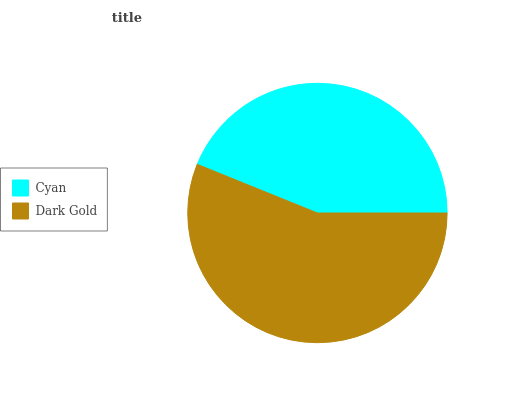Is Cyan the minimum?
Answer yes or no. Yes. Is Dark Gold the maximum?
Answer yes or no. Yes. Is Dark Gold the minimum?
Answer yes or no. No. Is Dark Gold greater than Cyan?
Answer yes or no. Yes. Is Cyan less than Dark Gold?
Answer yes or no. Yes. Is Cyan greater than Dark Gold?
Answer yes or no. No. Is Dark Gold less than Cyan?
Answer yes or no. No. Is Dark Gold the high median?
Answer yes or no. Yes. Is Cyan the low median?
Answer yes or no. Yes. Is Cyan the high median?
Answer yes or no. No. Is Dark Gold the low median?
Answer yes or no. No. 